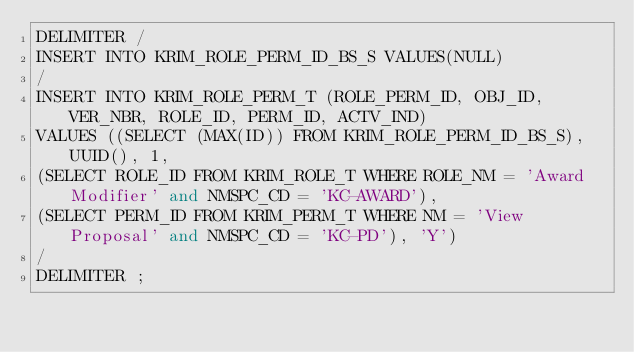<code> <loc_0><loc_0><loc_500><loc_500><_SQL_>DELIMITER /
INSERT INTO KRIM_ROLE_PERM_ID_BS_S VALUES(NULL)
/
INSERT INTO KRIM_ROLE_PERM_T (ROLE_PERM_ID, OBJ_ID, VER_NBR, ROLE_ID, PERM_ID, ACTV_IND)
VALUES ((SELECT (MAX(ID)) FROM KRIM_ROLE_PERM_ID_BS_S), UUID(), 1,
(SELECT ROLE_ID FROM KRIM_ROLE_T WHERE ROLE_NM = 'Award Modifier' and NMSPC_CD = 'KC-AWARD'),
(SELECT PERM_ID FROM KRIM_PERM_T WHERE NM = 'View Proposal' and NMSPC_CD = 'KC-PD'), 'Y')
/
DELIMITER ;
</code> 